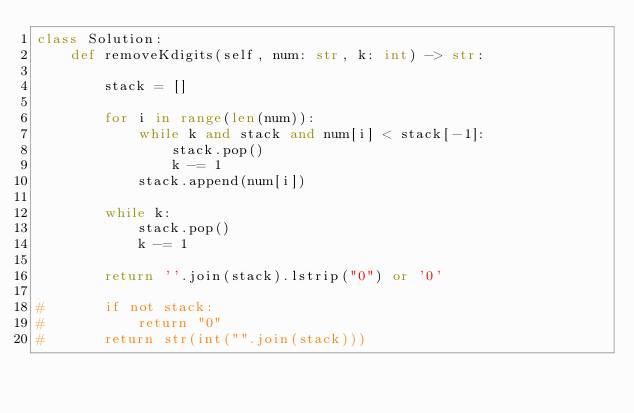Convert code to text. <code><loc_0><loc_0><loc_500><loc_500><_Python_>class Solution:
    def removeKdigits(self, num: str, k: int) -> str:

        stack = []

        for i in range(len(num)):
            while k and stack and num[i] < stack[-1]:
                stack.pop()
                k -= 1
            stack.append(num[i])

        while k:
            stack.pop()
            k -= 1

        return ''.join(stack).lstrip("0") or '0'

#       if not stack:
#           return "0"
#       return str(int("".join(stack)))</code> 